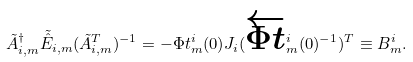<formula> <loc_0><loc_0><loc_500><loc_500>\tilde { A } ^ { \dag } _ { i , m } \tilde { \hat { E } } _ { i , m } ( \tilde { A } ^ { T } _ { i , m } ) ^ { - 1 } = - \Phi t ^ { i } _ { m } ( 0 ) J _ { i } ( \overleftarrow { \Phi t } ^ { i } _ { m } ( 0 ) ^ { - 1 } ) ^ { T } \equiv B ^ { i } _ { m } .</formula> 